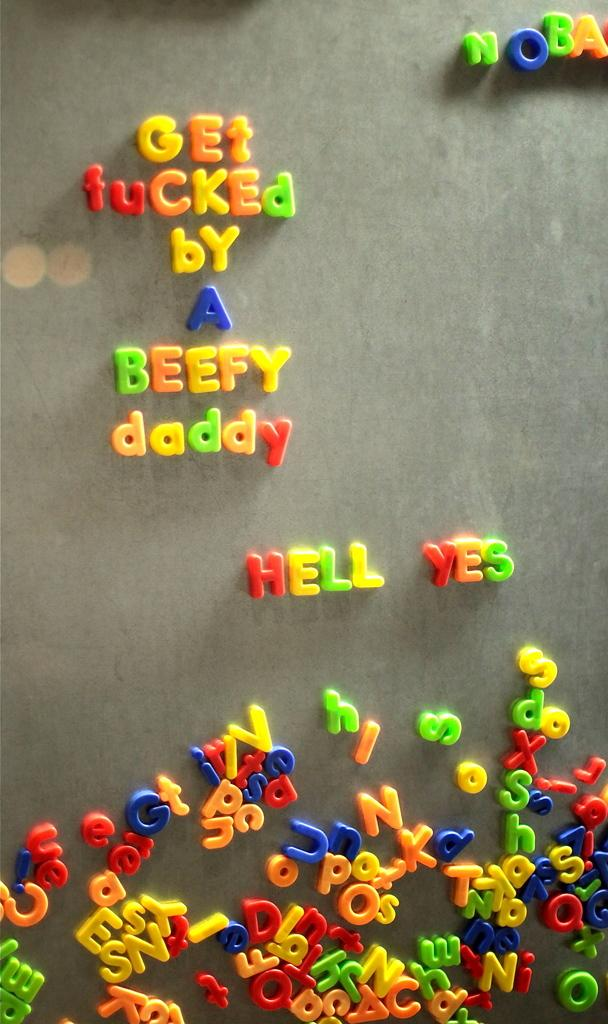What type of objects are present in the image? There are different colored alphabets in the image. Where are the alphabets located? The alphabets are on a surface. How many jellyfish can be seen swimming in the image? There are no jellyfish present in the image; it features different colored alphabets on a surface. 